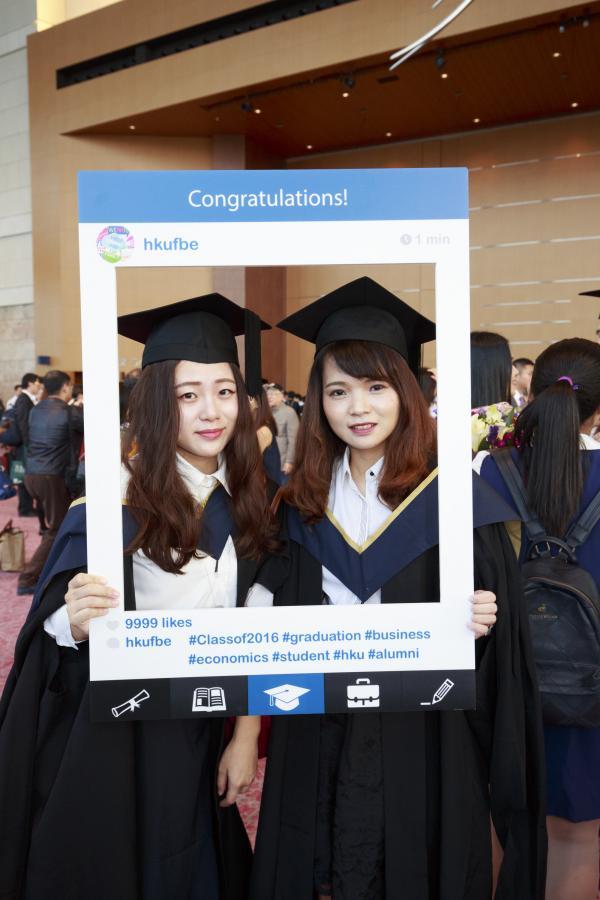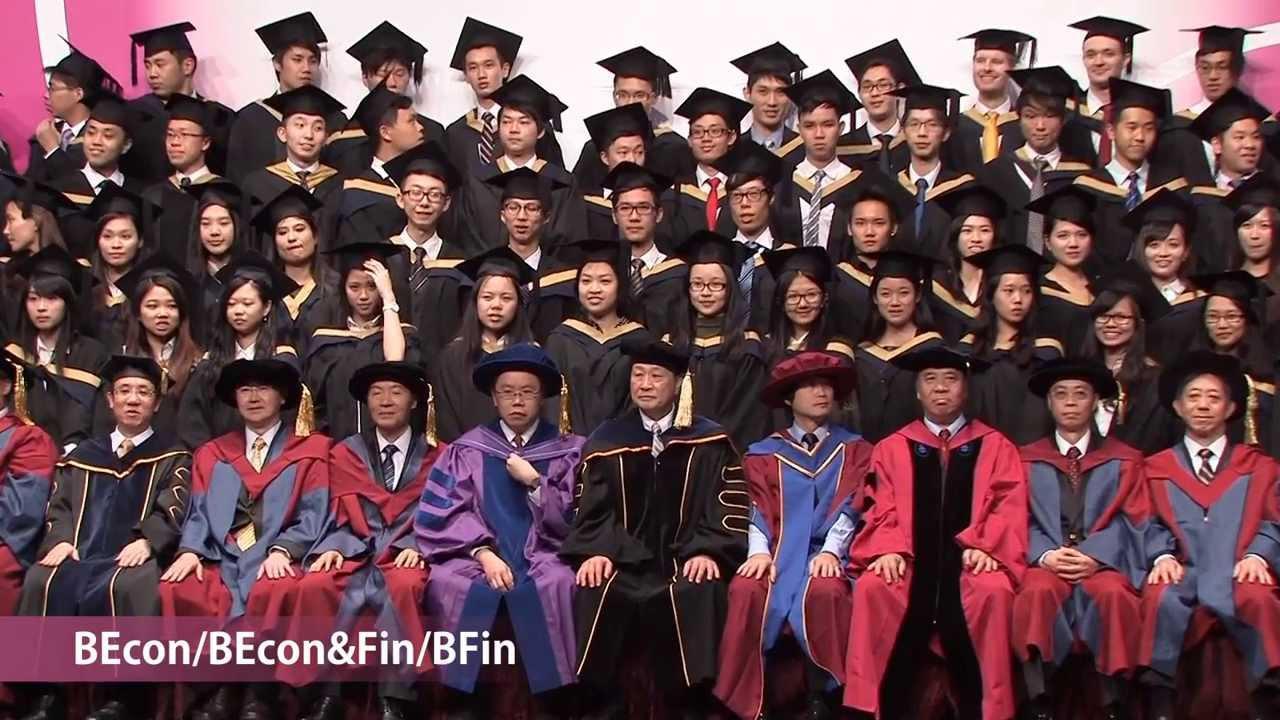The first image is the image on the left, the second image is the image on the right. For the images shown, is this caption "Two graduates pose for a picture in one of the images." true? Answer yes or no. Yes. 